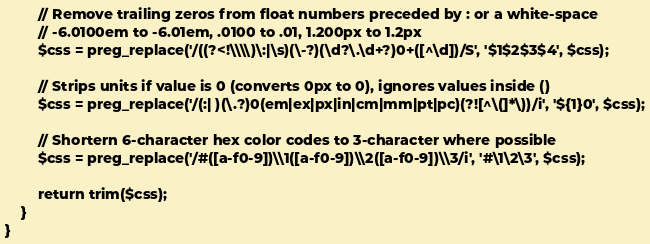Convert code to text. <code><loc_0><loc_0><loc_500><loc_500><_PHP_>
        // Remove trailing zeros from float numbers preceded by : or a white-space
        // -6.0100em to -6.01em, .0100 to .01, 1.200px to 1.2px
        $css = preg_replace('/((?<!\\\\)\:|\s)(\-?)(\d?\.\d+?)0+([^\d])/S', '$1$2$3$4', $css);

        // Strips units if value is 0 (converts 0px to 0), ignores values inside ()
        $css = preg_replace('/(:| )(\.?)0(em|ex|px|in|cm|mm|pt|pc)(?![^\(]*\))/i', '${1}0', $css);

        // Shortern 6-character hex color codes to 3-character where possible
        $css = preg_replace('/#([a-f0-9])\\1([a-f0-9])\\2([a-f0-9])\\3/i', '#\1\2\3', $css);

        return trim($css);
    }
}
</code> 